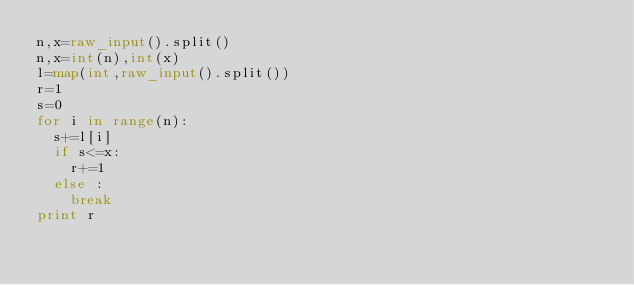<code> <loc_0><loc_0><loc_500><loc_500><_Python_>n,x=raw_input().split()
n,x=int(n),int(x)
l=map(int,raw_input().split())
r=1
s=0
for i in range(n):
  s+=l[i]
  if s<=x:
    r+=1
  else :
    break
print r</code> 